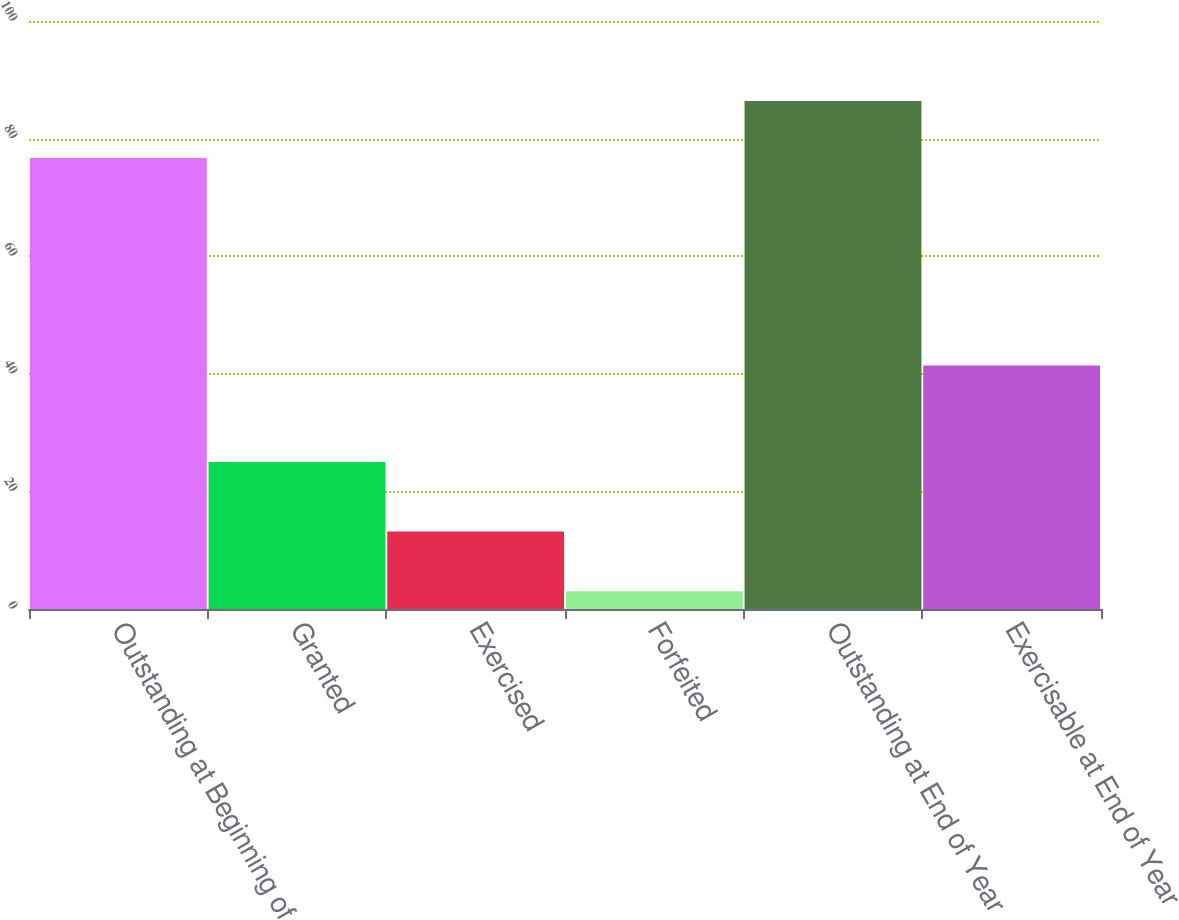Convert chart. <chart><loc_0><loc_0><loc_500><loc_500><bar_chart><fcel>Outstanding at Beginning of<fcel>Granted<fcel>Exercised<fcel>Forfeited<fcel>Outstanding at End of Year<fcel>Exercisable at End of Year<nl><fcel>76.7<fcel>25<fcel>13.2<fcel>3<fcel>86.4<fcel>41.4<nl></chart> 